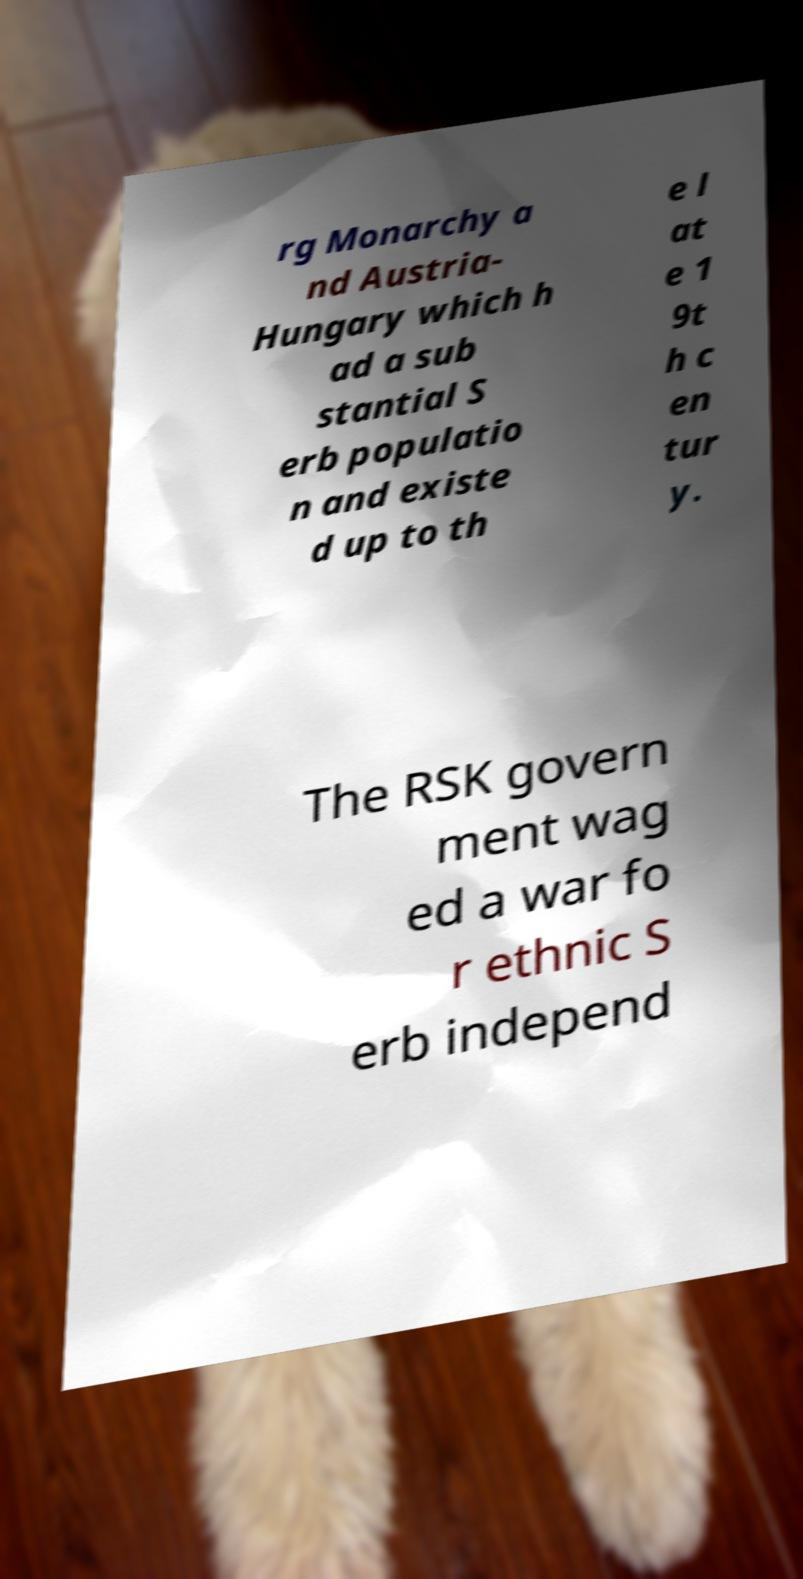Can you read and provide the text displayed in the image?This photo seems to have some interesting text. Can you extract and type it out for me? rg Monarchy a nd Austria- Hungary which h ad a sub stantial S erb populatio n and existe d up to th e l at e 1 9t h c en tur y. The RSK govern ment wag ed a war fo r ethnic S erb independ 